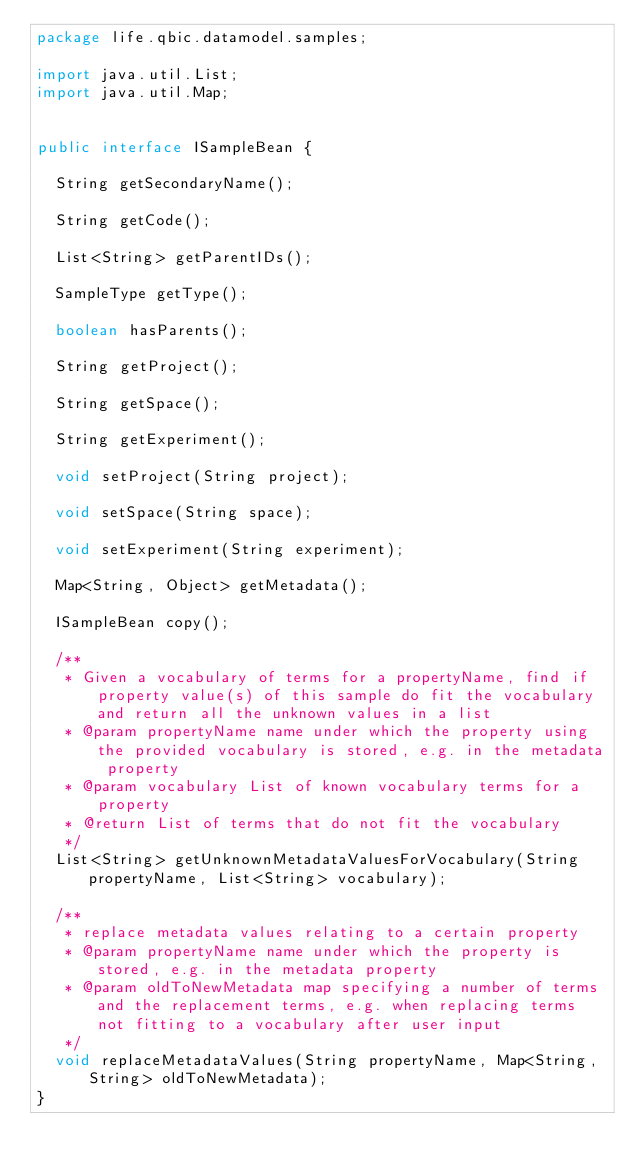<code> <loc_0><loc_0><loc_500><loc_500><_Java_>package life.qbic.datamodel.samples;

import java.util.List;
import java.util.Map;


public interface ISampleBean {

  String getSecondaryName();

  String getCode();

  List<String> getParentIDs();

  SampleType getType();

  boolean hasParents();

  String getProject();

  String getSpace();

  String getExperiment();

  void setProject(String project);

  void setSpace(String space);

  void setExperiment(String experiment);

  Map<String, Object> getMetadata();

  ISampleBean copy();

  /**
   * Given a vocabulary of terms for a propertyName, find if property value(s) of this sample do fit the vocabulary and return all the unknown values in a list
   * @param propertyName name under which the property using the provided vocabulary is stored, e.g. in the metadata property
   * @param vocabulary List of known vocabulary terms for a property
   * @return List of terms that do not fit the vocabulary
   */
  List<String> getUnknownMetadataValuesForVocabulary(String propertyName, List<String> vocabulary);

  /**
   * replace metadata values relating to a certain property
   * @param propertyName name under which the property is stored, e.g. in the metadata property
   * @param oldToNewMetadata map specifying a number of terms and the replacement terms, e.g. when replacing terms not fitting to a vocabulary after user input
   */
  void replaceMetadataValues(String propertyName, Map<String, String> oldToNewMetadata);
}
</code> 